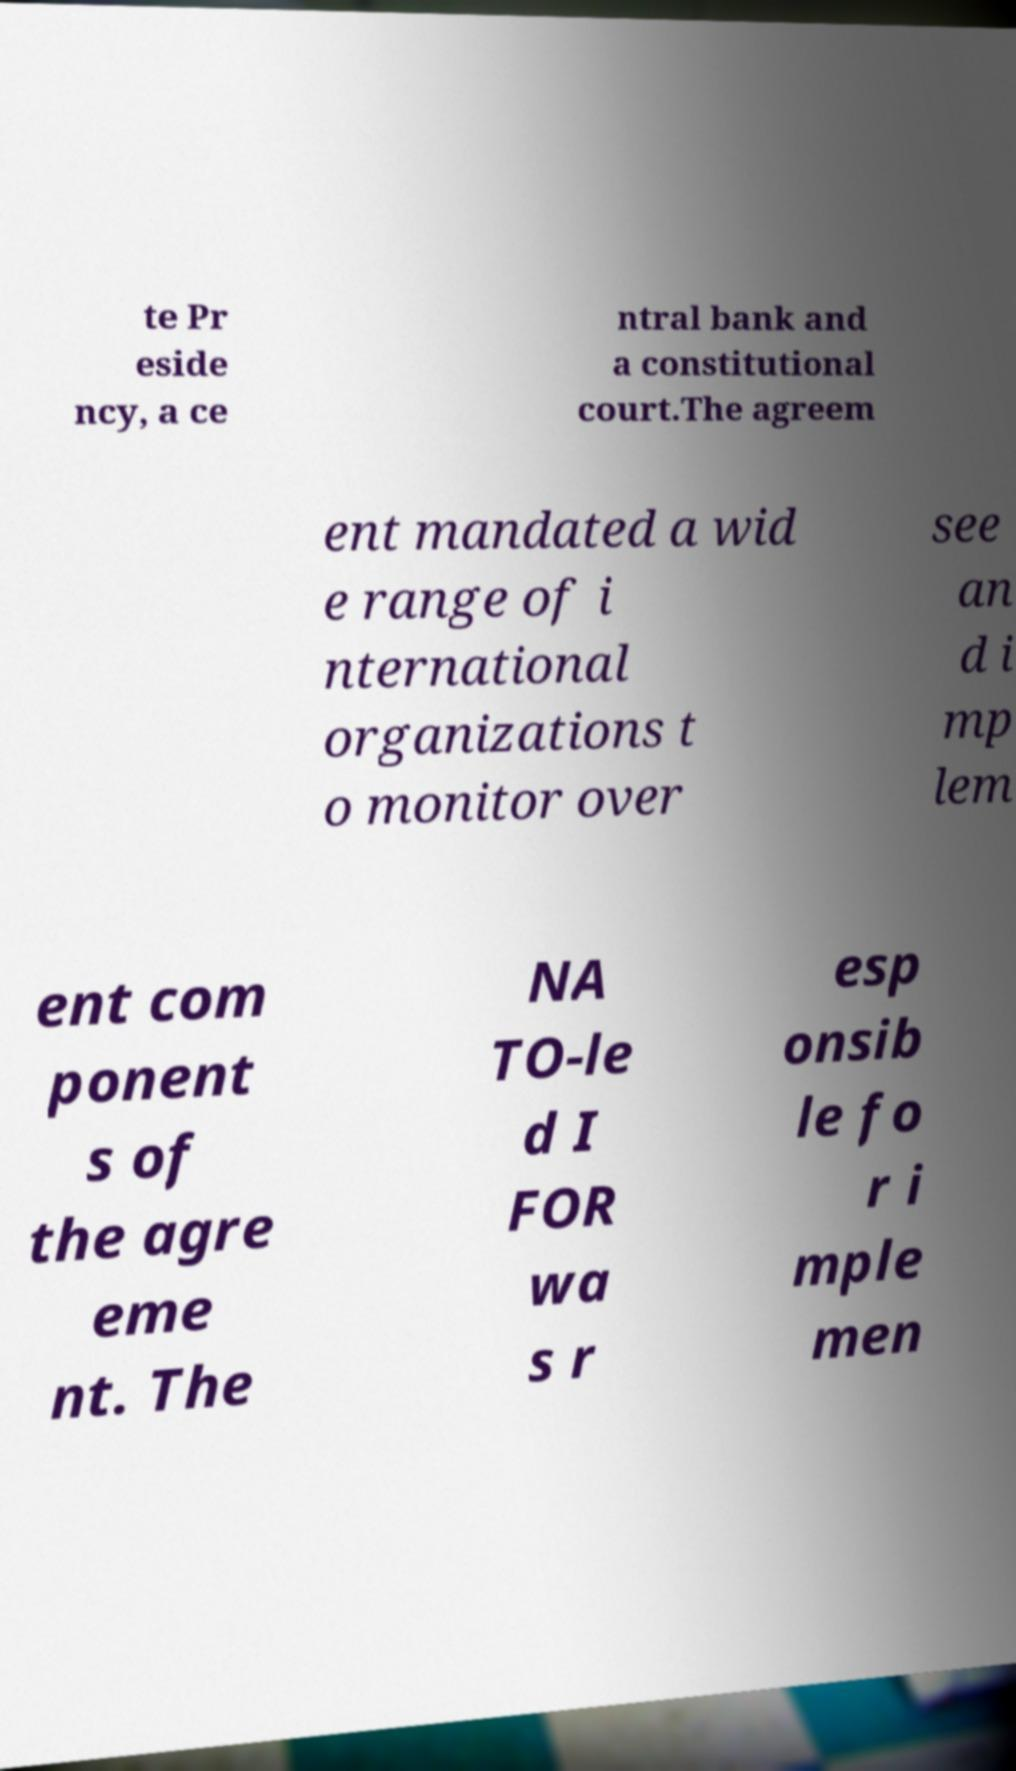For documentation purposes, I need the text within this image transcribed. Could you provide that? te Pr eside ncy, a ce ntral bank and a constitutional court.The agreem ent mandated a wid e range of i nternational organizations t o monitor over see an d i mp lem ent com ponent s of the agre eme nt. The NA TO-le d I FOR wa s r esp onsib le fo r i mple men 